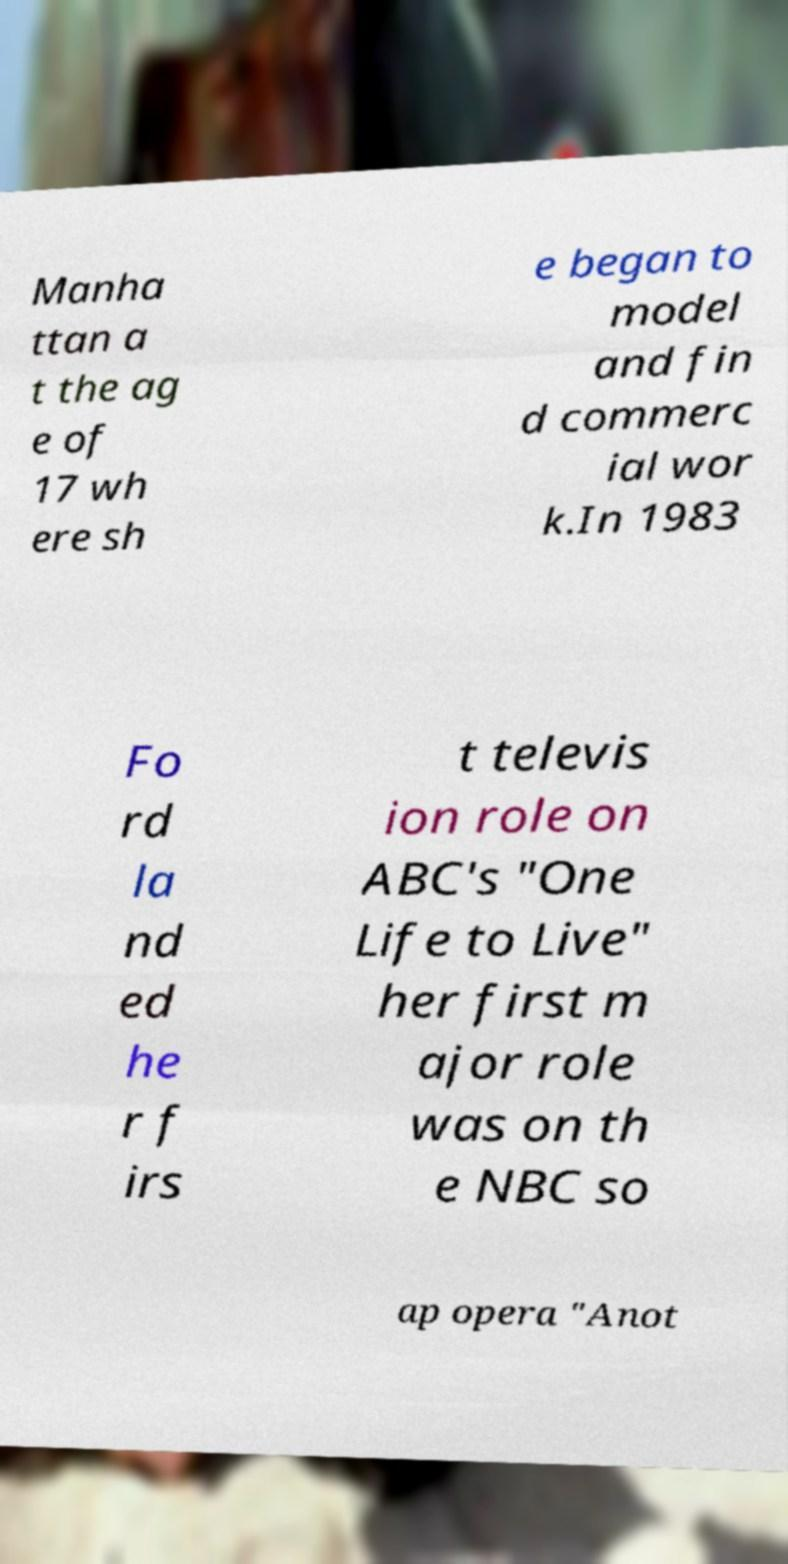Can you read and provide the text displayed in the image?This photo seems to have some interesting text. Can you extract and type it out for me? Manha ttan a t the ag e of 17 wh ere sh e began to model and fin d commerc ial wor k.In 1983 Fo rd la nd ed he r f irs t televis ion role on ABC's "One Life to Live" her first m ajor role was on th e NBC so ap opera "Anot 